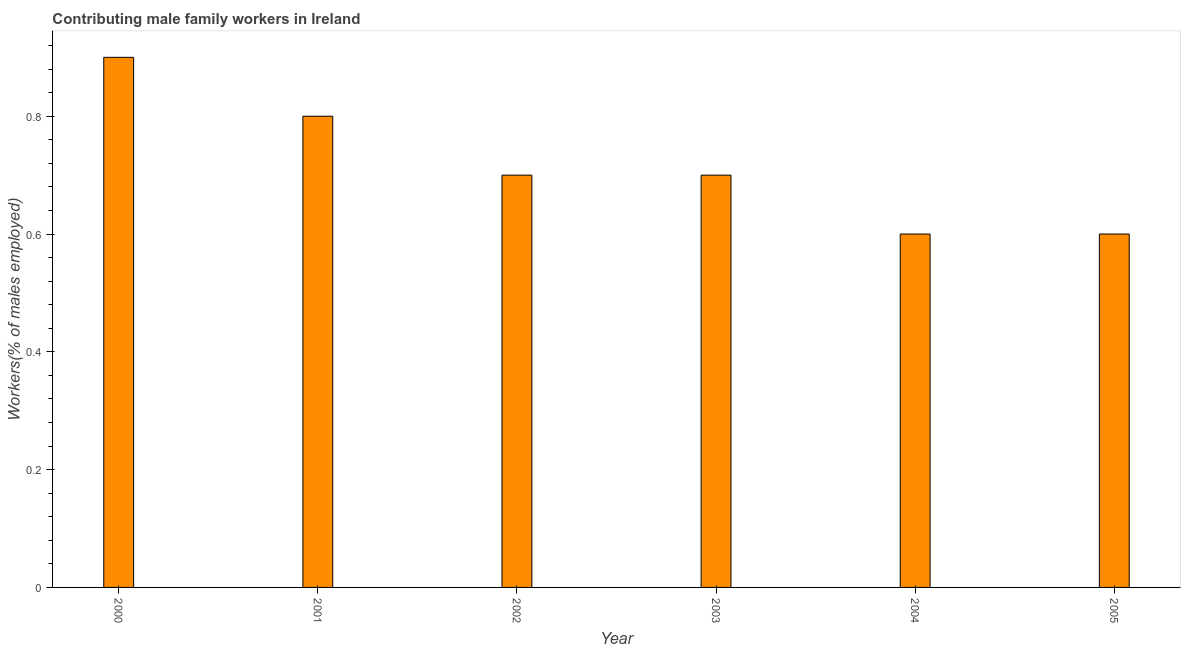Does the graph contain any zero values?
Your answer should be very brief. No. Does the graph contain grids?
Offer a very short reply. No. What is the title of the graph?
Your response must be concise. Contributing male family workers in Ireland. What is the label or title of the X-axis?
Ensure brevity in your answer.  Year. What is the label or title of the Y-axis?
Your answer should be compact. Workers(% of males employed). What is the contributing male family workers in 2002?
Your answer should be compact. 0.7. Across all years, what is the maximum contributing male family workers?
Keep it short and to the point. 0.9. Across all years, what is the minimum contributing male family workers?
Keep it short and to the point. 0.6. In which year was the contributing male family workers maximum?
Offer a terse response. 2000. What is the sum of the contributing male family workers?
Provide a succinct answer. 4.3. What is the difference between the contributing male family workers in 2000 and 2001?
Offer a terse response. 0.1. What is the average contributing male family workers per year?
Ensure brevity in your answer.  0.72. What is the median contributing male family workers?
Give a very brief answer. 0.7. What is the ratio of the contributing male family workers in 2003 to that in 2004?
Offer a terse response. 1.17. Is the contributing male family workers in 2003 less than that in 2005?
Provide a short and direct response. No. Is the difference between the contributing male family workers in 2003 and 2005 greater than the difference between any two years?
Make the answer very short. No. What is the difference between the highest and the second highest contributing male family workers?
Offer a very short reply. 0.1. Is the sum of the contributing male family workers in 2002 and 2004 greater than the maximum contributing male family workers across all years?
Make the answer very short. Yes. What is the difference between the highest and the lowest contributing male family workers?
Ensure brevity in your answer.  0.3. In how many years, is the contributing male family workers greater than the average contributing male family workers taken over all years?
Your answer should be compact. 2. How many bars are there?
Make the answer very short. 6. How many years are there in the graph?
Offer a terse response. 6. What is the difference between two consecutive major ticks on the Y-axis?
Provide a short and direct response. 0.2. What is the Workers(% of males employed) of 2000?
Your answer should be very brief. 0.9. What is the Workers(% of males employed) of 2001?
Keep it short and to the point. 0.8. What is the Workers(% of males employed) of 2002?
Offer a very short reply. 0.7. What is the Workers(% of males employed) in 2003?
Your response must be concise. 0.7. What is the Workers(% of males employed) of 2004?
Your answer should be compact. 0.6. What is the Workers(% of males employed) in 2005?
Provide a short and direct response. 0.6. What is the difference between the Workers(% of males employed) in 2000 and 2003?
Offer a terse response. 0.2. What is the difference between the Workers(% of males employed) in 2000 and 2004?
Provide a short and direct response. 0.3. What is the difference between the Workers(% of males employed) in 2001 and 2002?
Your answer should be compact. 0.1. What is the difference between the Workers(% of males employed) in 2001 and 2003?
Provide a short and direct response. 0.1. What is the difference between the Workers(% of males employed) in 2001 and 2004?
Provide a succinct answer. 0.2. What is the ratio of the Workers(% of males employed) in 2000 to that in 2002?
Give a very brief answer. 1.29. What is the ratio of the Workers(% of males employed) in 2000 to that in 2003?
Your answer should be compact. 1.29. What is the ratio of the Workers(% of males employed) in 2000 to that in 2004?
Provide a succinct answer. 1.5. What is the ratio of the Workers(% of males employed) in 2000 to that in 2005?
Offer a terse response. 1.5. What is the ratio of the Workers(% of males employed) in 2001 to that in 2002?
Provide a short and direct response. 1.14. What is the ratio of the Workers(% of males employed) in 2001 to that in 2003?
Keep it short and to the point. 1.14. What is the ratio of the Workers(% of males employed) in 2001 to that in 2004?
Give a very brief answer. 1.33. What is the ratio of the Workers(% of males employed) in 2001 to that in 2005?
Provide a succinct answer. 1.33. What is the ratio of the Workers(% of males employed) in 2002 to that in 2004?
Provide a succinct answer. 1.17. What is the ratio of the Workers(% of males employed) in 2002 to that in 2005?
Give a very brief answer. 1.17. What is the ratio of the Workers(% of males employed) in 2003 to that in 2004?
Ensure brevity in your answer.  1.17. What is the ratio of the Workers(% of males employed) in 2003 to that in 2005?
Make the answer very short. 1.17. 